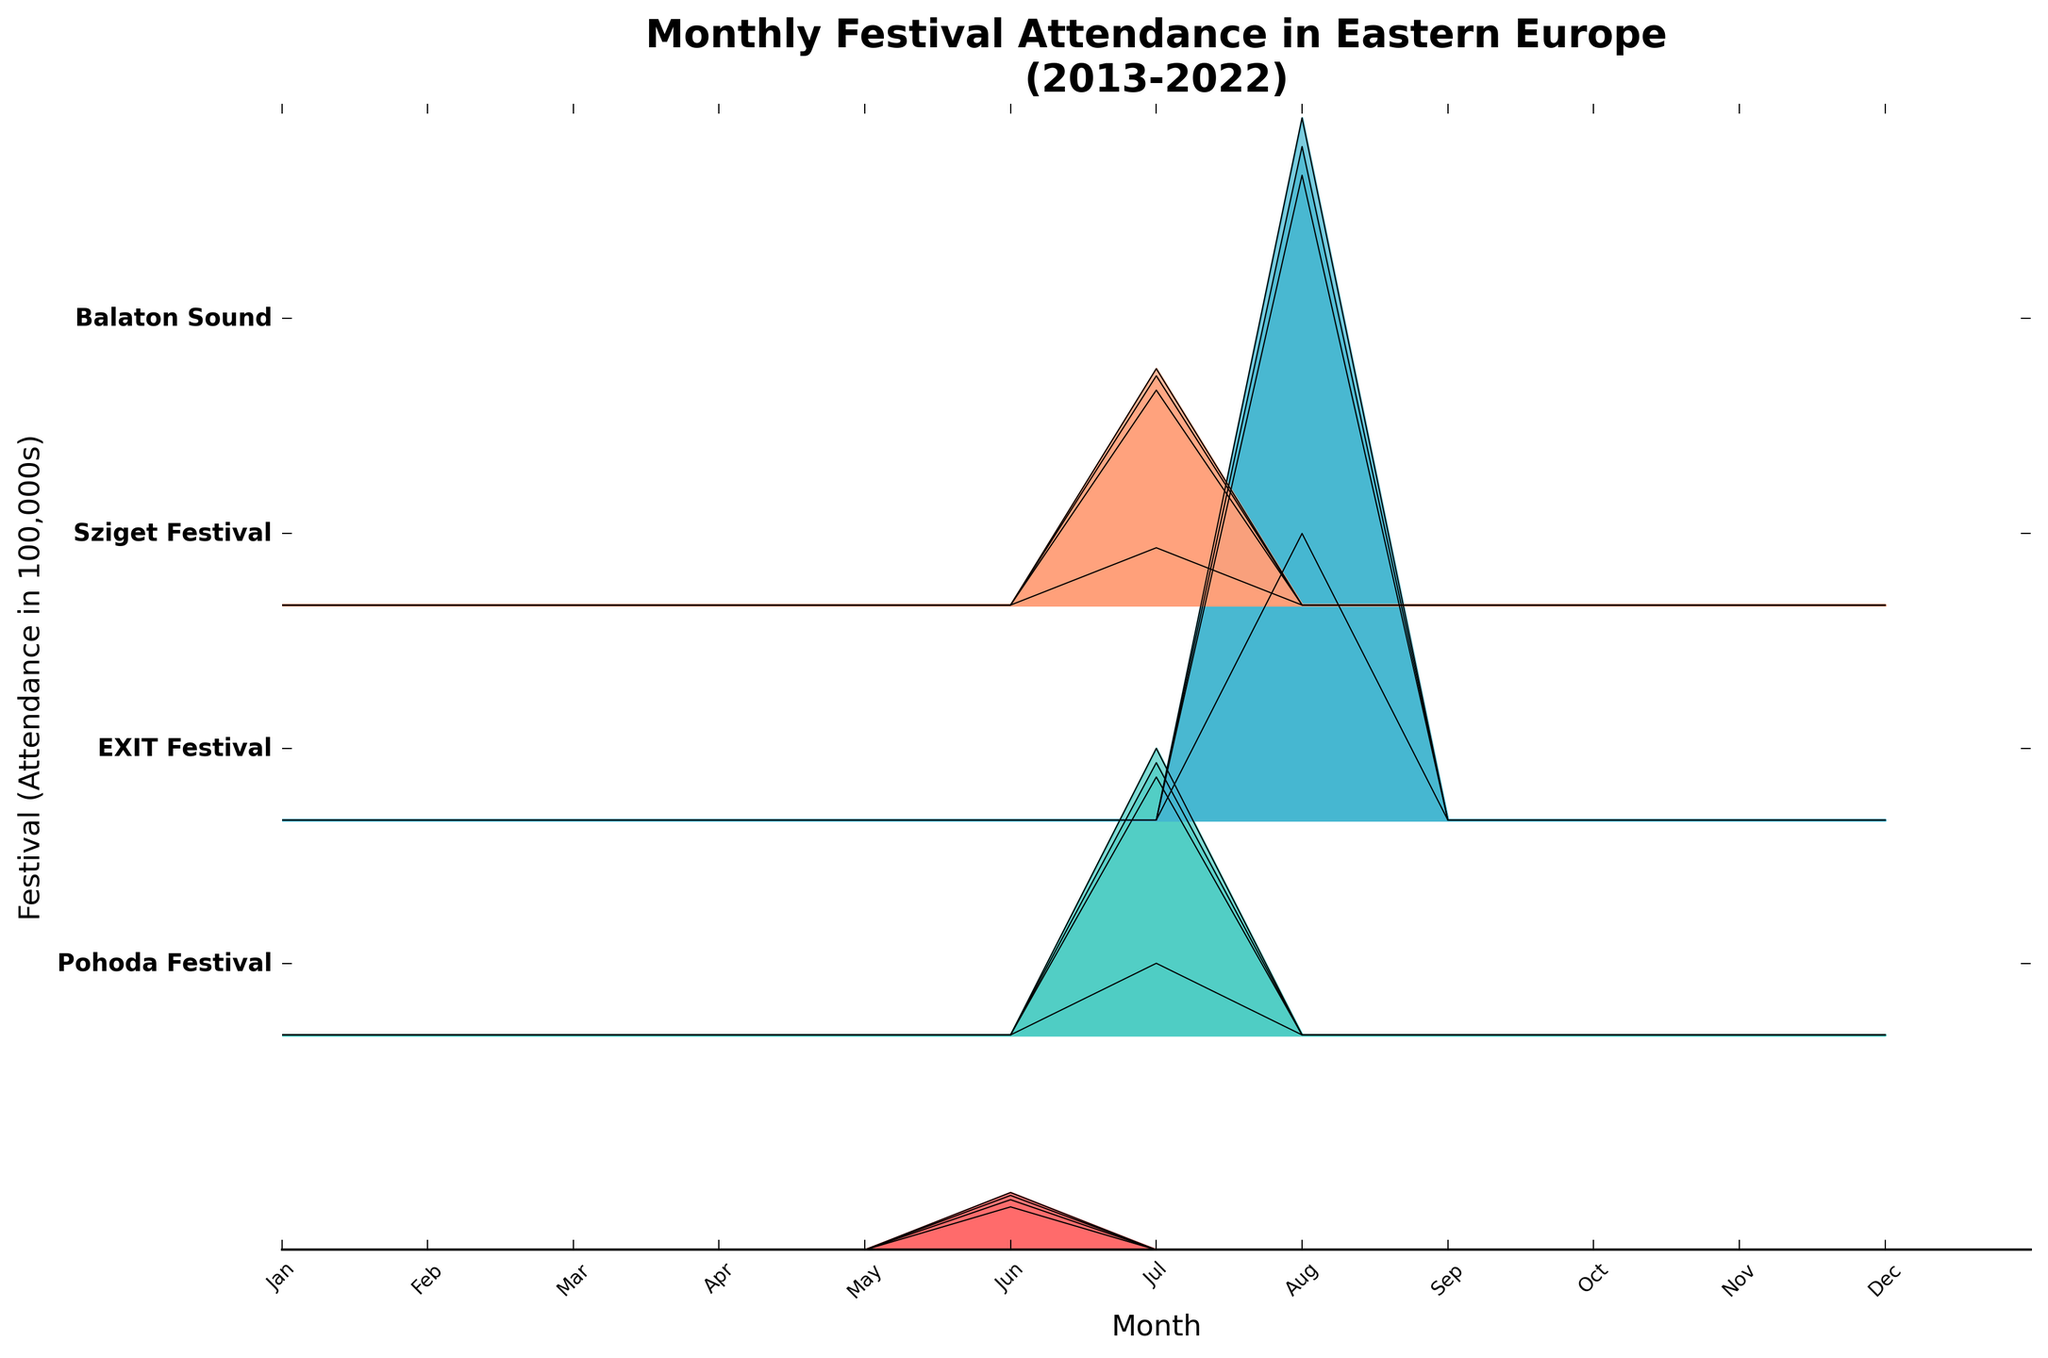What's the title of the figure? The title of a figure is usually located at the top and provides a concise summary of the plot's content. In this case, the title reads "Monthly Festival Attendance in Eastern Europe (2013-2022)".
Answer: Monthly Festival Attendance in Eastern Europe (2013-2022) During which month does the Pohoda Festival take place? The Ridgeline plot uses different months on the x-axis and each festival has a peak during its respective month. For the Pohoda Festival, the peak occurs in June, as indicated by the high attendance values in that month across the years.
Answer: June Which festival has the highest peak attendance in any given month? By comparing the height of the attendance peaks for different festivals, the Sziget Festival shows the highest peak, particularly in August, with an attendance reaching 490,000 in 2019.
Answer: Sziget Festival In what year did the EXIT Festival see its lowest monthly attendance in July? Looking at the peaks for the EXIT Festival in July across different years, the lowest attendance is in 2020 where it dropped significantly to 50,000.
Answer: 2020 Which festival has an attendance peak in August only? By observing the months with peaks for each festival, it's clear that the Sziget Festival is the only one peaking in August.
Answer: Sziget Festival How does the peak attendance for Balaton Sound in 2020 compare to 2022? By observing the heights of the attendance peaks for Balaton Sound in 2020 and 2022, you can see that 2020 peak is lower, specifically at 40,000, whereas the 2022 peak is higher at 160,000.
Answer: It's lower in 2020 Which festival's attendance did not change between 2015 and 2017? By comparing the heights of the peaks for each festival across the years, the Pohoda Festival shows equal peak heights in 2015 and 2017, both around 35,000 and 38,000 respectively, but this insight can be finalized at seeing the almost similar plot on Y-axis.
Answer: Pohoda Festival Which month has no events across all festivals in any given year? By scanning the entire x-axis for empty or zero-level peaks across all festival entries, no events are recorded in the months of January, February, March, April, November, and December.
Answer: January, February, March, April, November, December Identify a trend in the attendance of the Pohoda Festival from 2013 to 2019. By observing the peaks of the Pohoda Festival over the specified years, it shows a positive trend with an increase in peak attendance from 30,000 in 2013 to 40,000 in 2019.
Answer: Increasing trend 